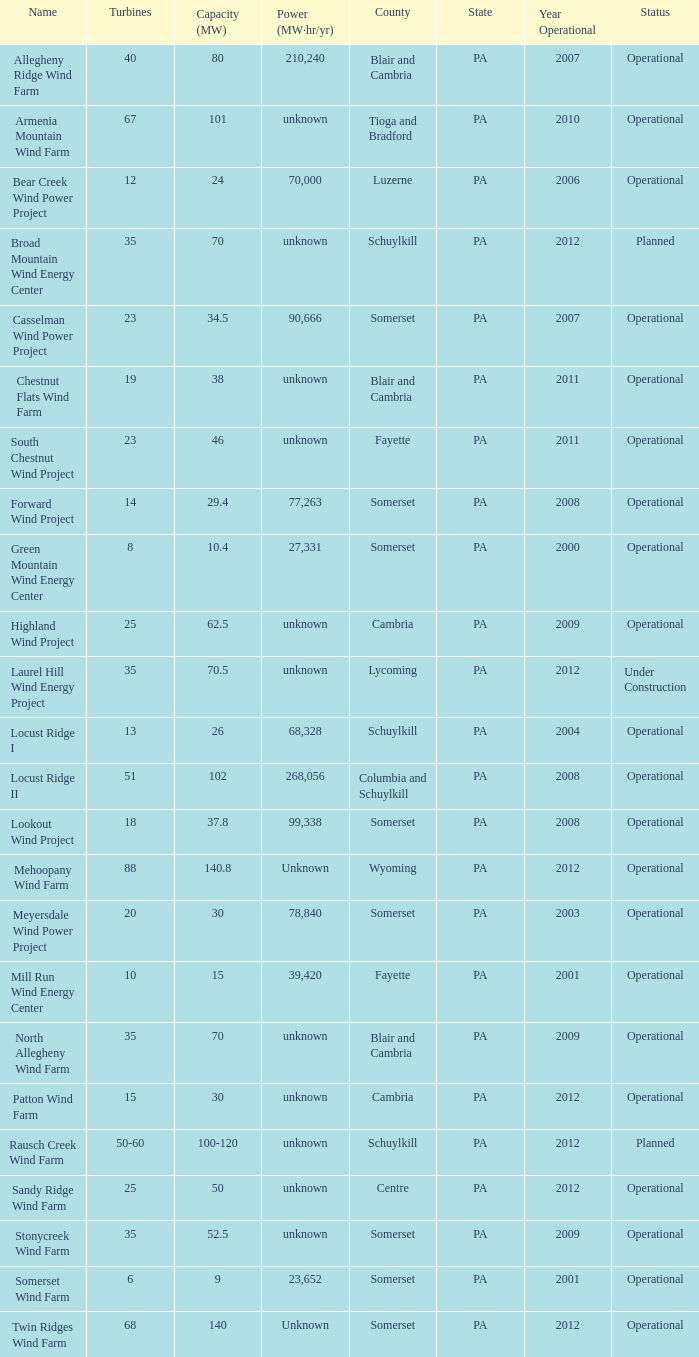What all turbines have a capacity of 30 and have a Somerset location? 20.0. 